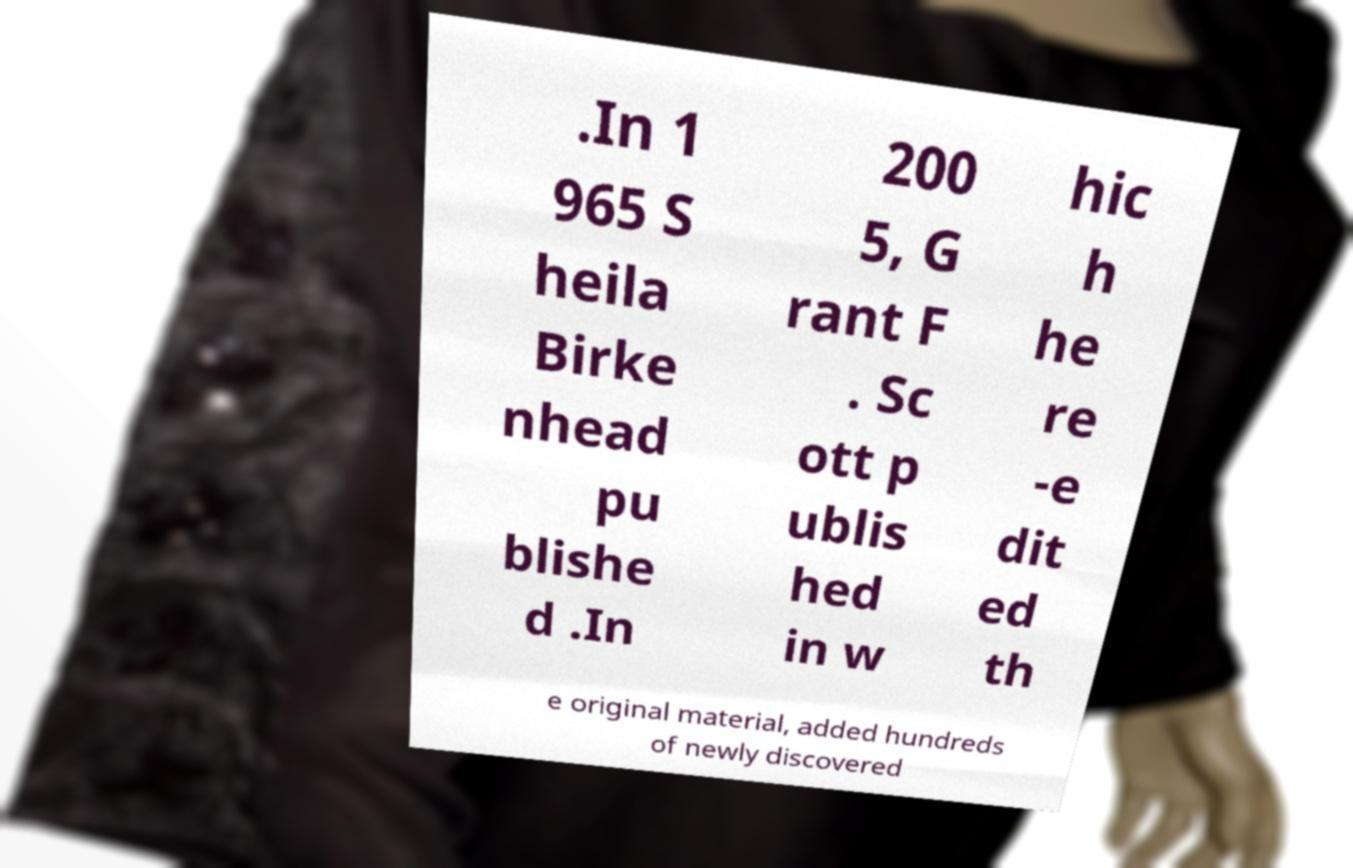Could you assist in decoding the text presented in this image and type it out clearly? .In 1 965 S heila Birke nhead pu blishe d .In 200 5, G rant F . Sc ott p ublis hed in w hic h he re -e dit ed th e original material, added hundreds of newly discovered 